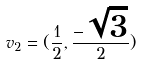<formula> <loc_0><loc_0><loc_500><loc_500>v _ { 2 } = ( \frac { 1 } { 2 } , \frac { - \sqrt { 3 } } { 2 } )</formula> 